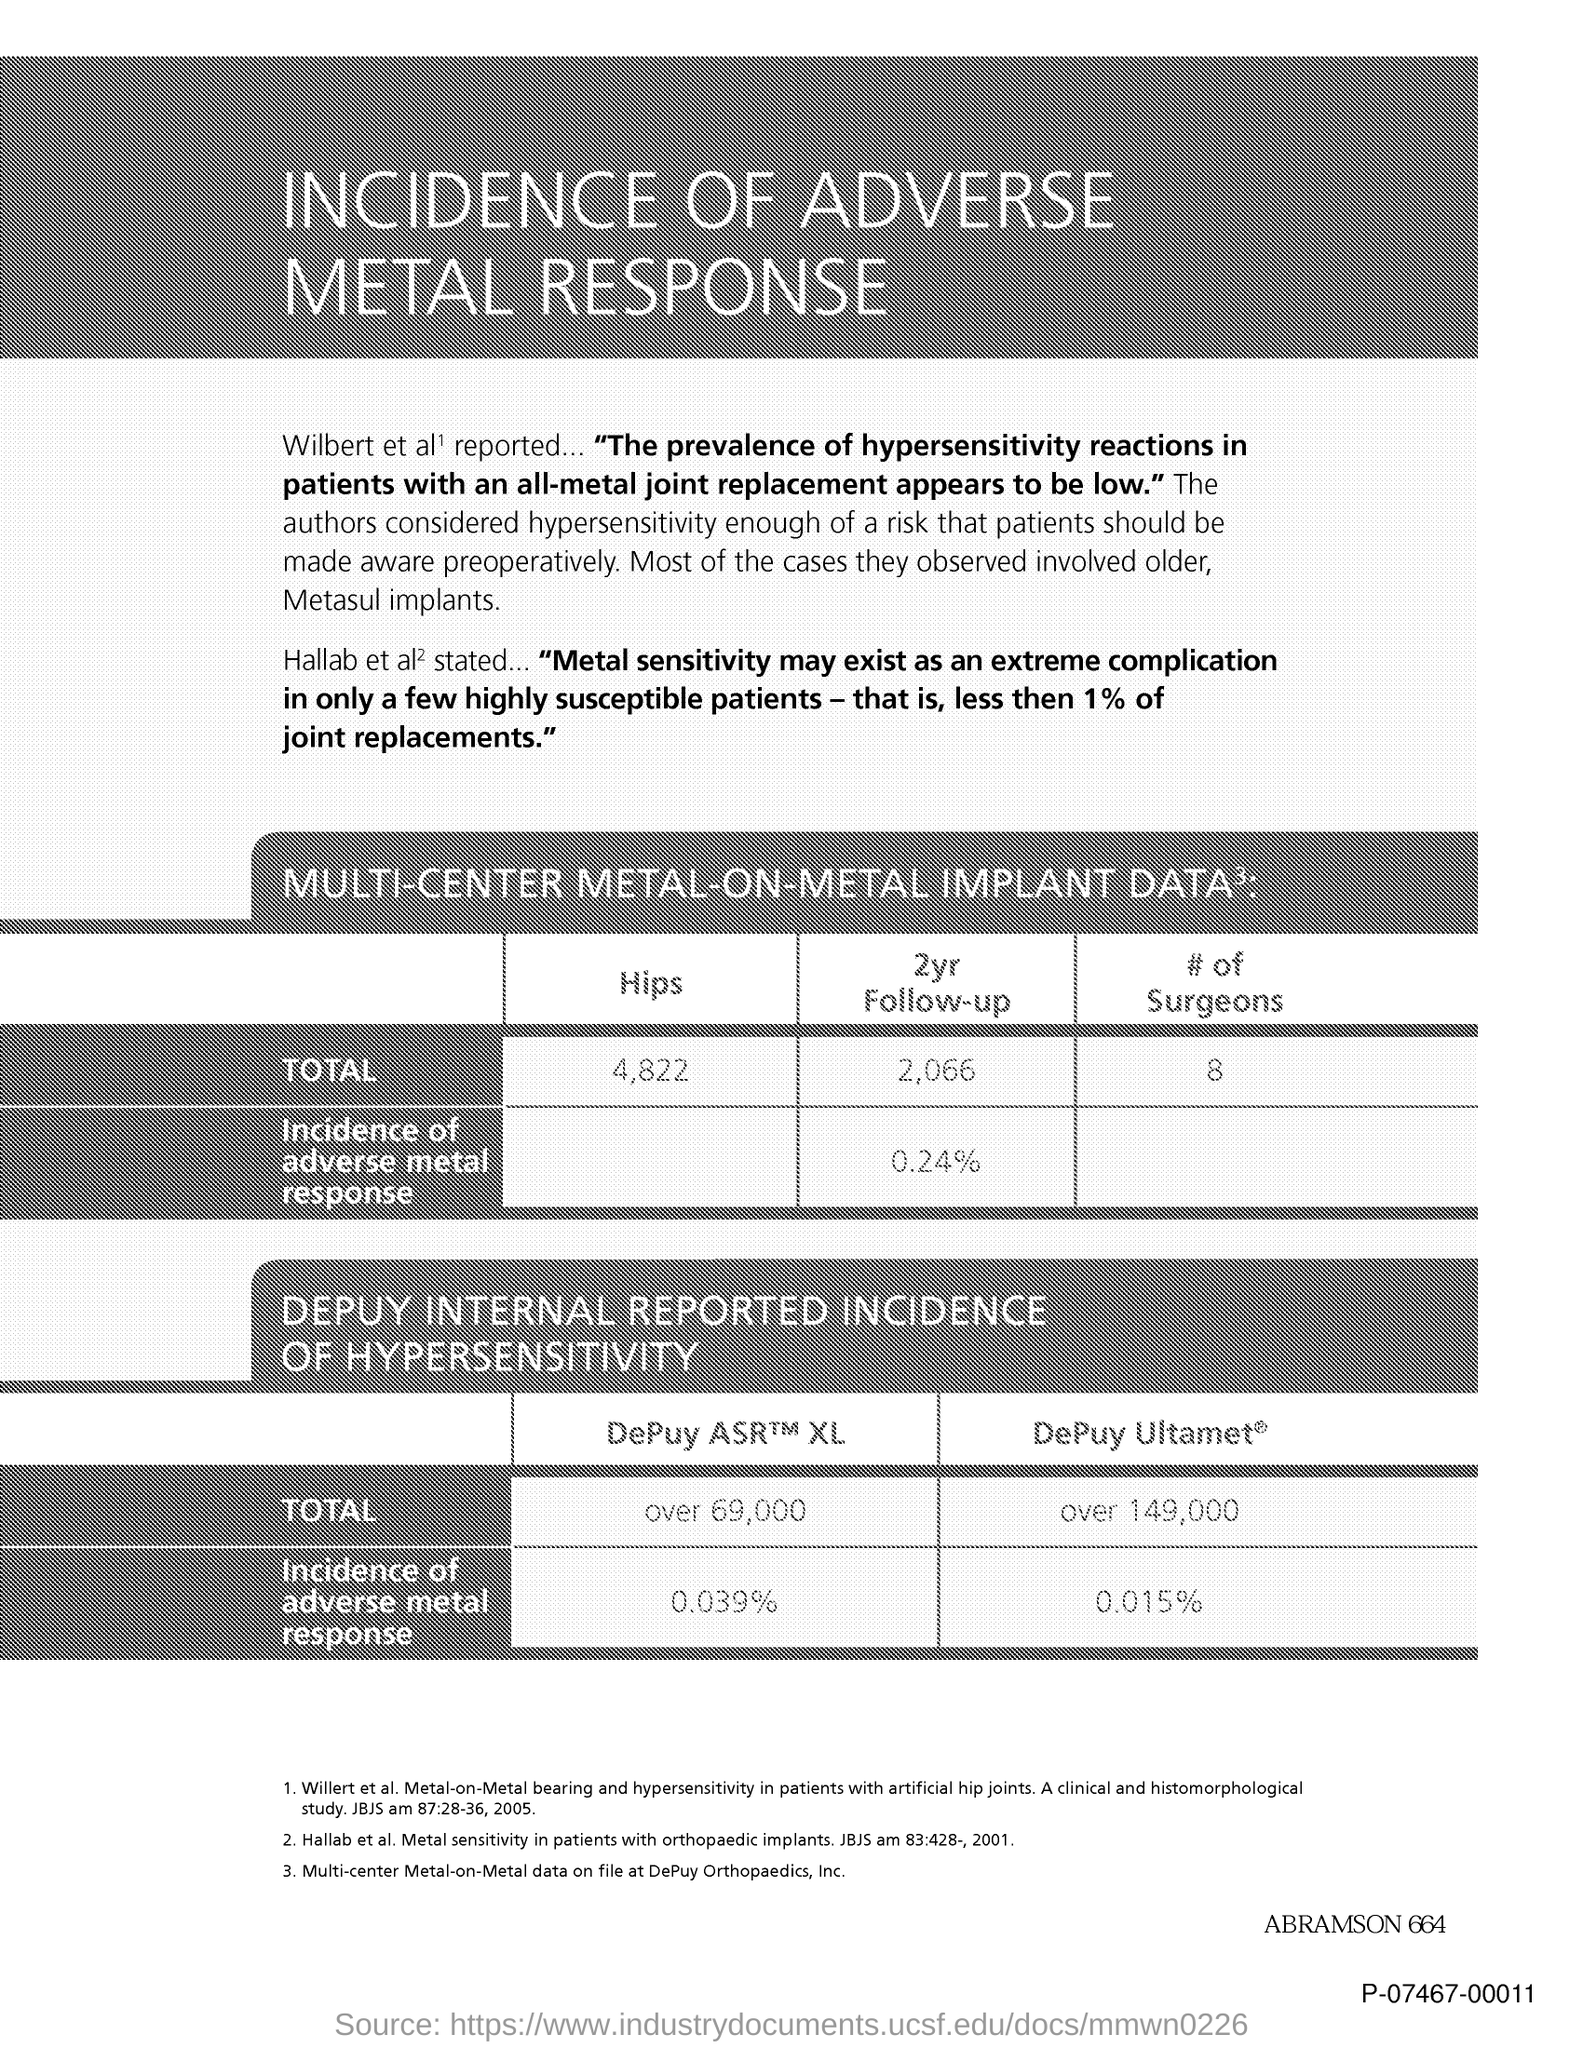Mention a couple of crucial points in this snapshot. The document's title is 'Incidence of adverse metal response.' The total number of hips is 4,822. 